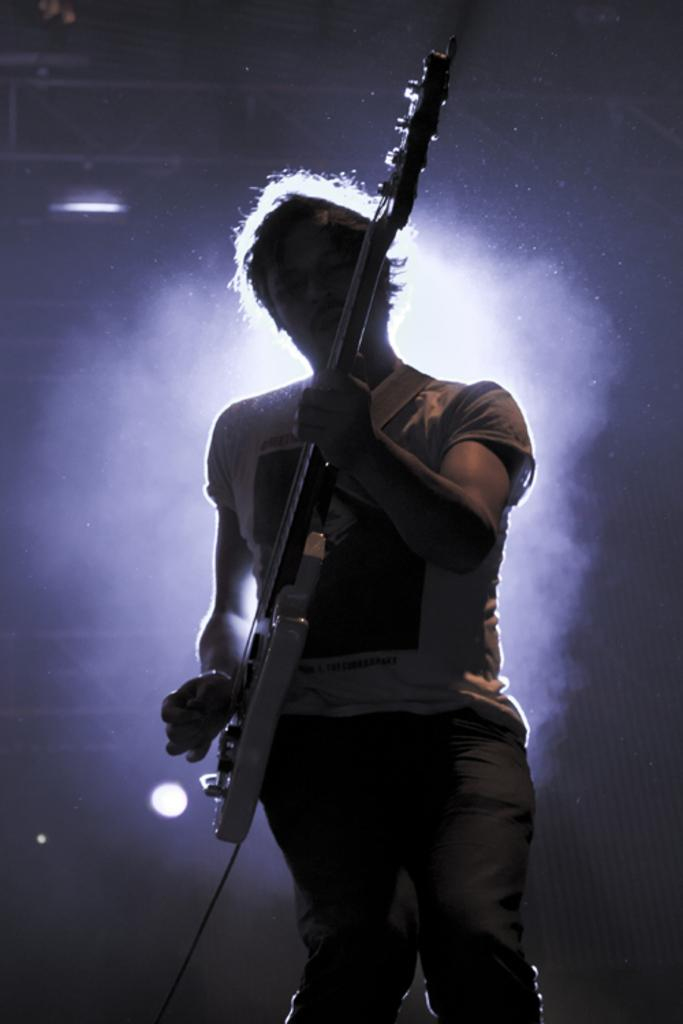What is the main subject of the image? The main subject of the image is a man. What is the man doing in the image? The man is standing and playing a guitar. What type of fear is the man experiencing while playing the guitar in the image? There is no indication of fear in the image; the man is simply playing the guitar. What type of acoustics can be heard from the guitar in the image? The image is a still image and does not provide any auditory information, so it is impossible to determine the acoustics of the guitar. 